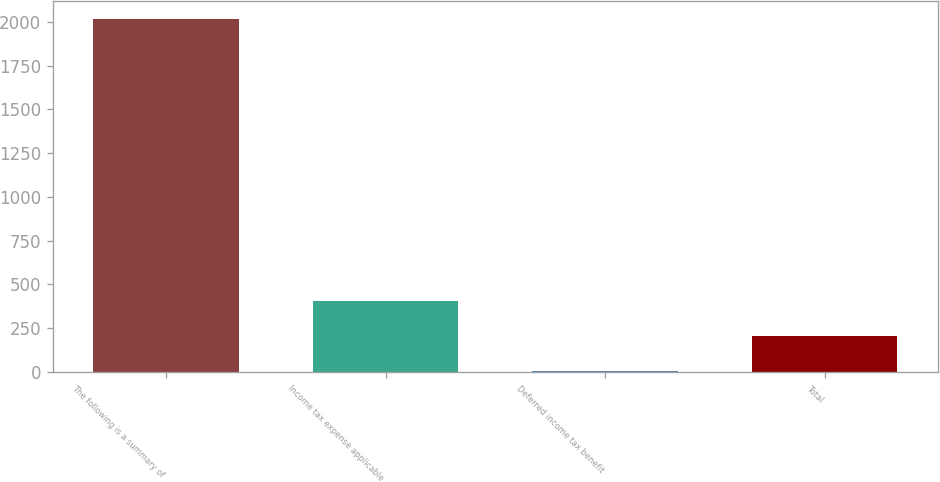Convert chart. <chart><loc_0><loc_0><loc_500><loc_500><bar_chart><fcel>The following is a summary of<fcel>Income tax expense applicable<fcel>Deferred income tax benefit<fcel>Total<nl><fcel>2015<fcel>407.24<fcel>5.3<fcel>206.27<nl></chart> 